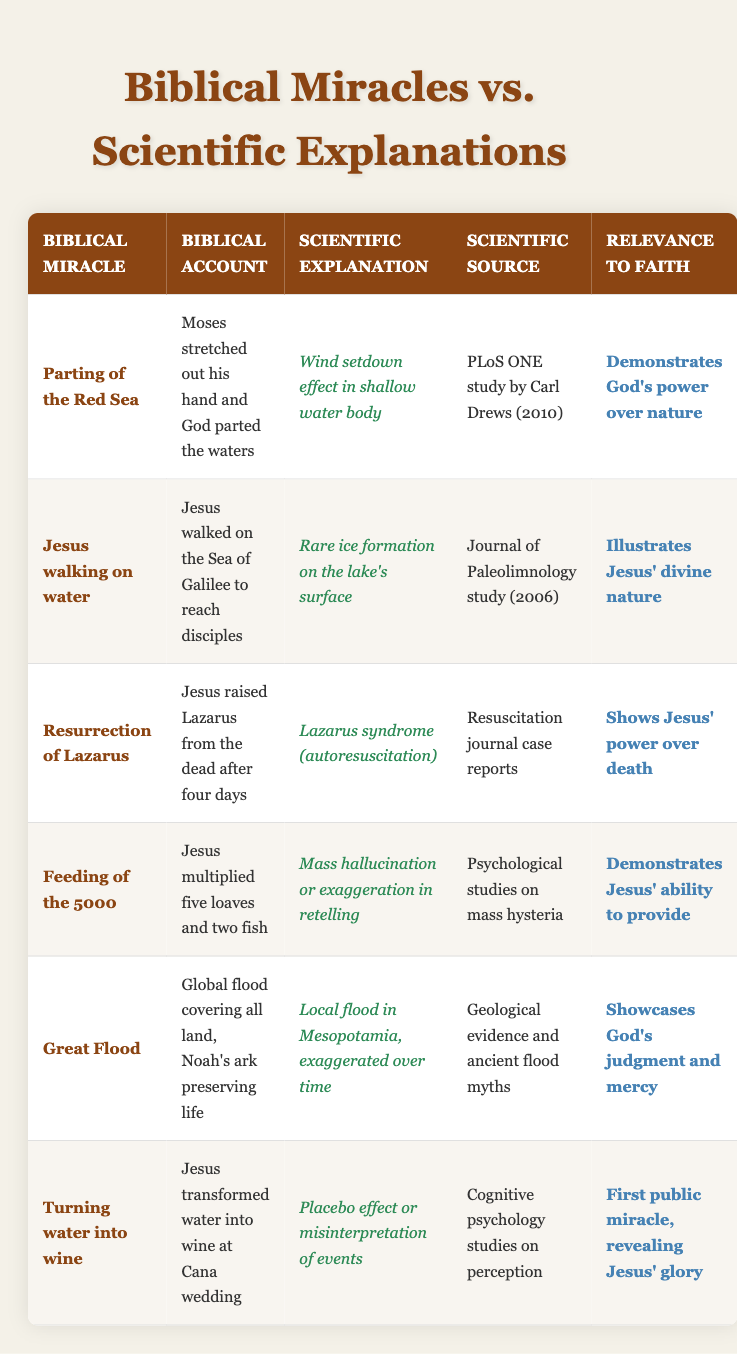What is the biblical account for the miracle of the Great Flood? The biblical account for the Great Flood states that there was a global flood covering all land, with Noah's ark preserving life. This detail can be found in the "Biblical Account" column for the Great Flood row in the table.
Answer: There was a global flood covering all land, Noah's ark preserving life What scientific explanation is provided for Jesus walking on water? The table lists the scientific explanation for Jesus walking on water as a rare ice formation on the lake's surface. This information is located in the "Scientific Explanation" column for the relevant miracle row.
Answer: Rare ice formation on the lake's surface How many miracles mentioned in the table showcase Jesus' power? To determine this, I will count the rows where the relevance to faith includes a demonstration of Jesus' power. The miracles are: Resurrection of Lazarus (power over death), Jesus walking on water (divine nature), and Feeding of the 5000 (ability to provide). Thus, there are three miracles.
Answer: 3 Is the scientific source for the Parting of the Red Sea a journal study? The source listed for the Parting of the Red Sea is the PLoS ONE study by Carl Drews (2010), which is indeed a scientific journal study. This confirmation can be derived from the "Scientific Source" column corresponding to that miracle.
Answer: Yes Which miracle has a relevance to faith related to God's judgment and mercy? The Great Flood miracle is noted for showcasing God's judgment and mercy. This can be identified by looking at the "Relevance to Faith" column for this particular miracle row.
Answer: Great Flood What is the relationship between the miracle of turning water into wine and Jesus' glory? The relevance to faith for the miracle of turning water into wine indicates that it was Jesus' first public miracle, revealing His glory. This idea is reflected in the "Relevance to Faith" column for that miracle.
Answer: Revealing Jesus' glory List the scientific sources for the miracles involving Lazarus and the Feeding of the 5000. The scientific source for the Resurrection of Lazarus is listed as Resuscitation journal case reports, and for the Feeding of the 5000, it is noted as psychological studies on mass hysteria. This information can be retrieved by looking at the "Scientific Source" column in those specific rows.
Answer: Resuscitation journal case reports; psychological studies on mass hysteria What was the main scientific explanation for the feeding of the 5000 miracle? According to the table, the scientific explanation for the miracle of the feeding of the 5000 is attributed to mass hallucination or exaggeration in retelling. This can be found in the "Scientific Explanation" column for that row.
Answer: Mass hallucination or exaggeration in retelling Which miracle has the most complex scientific explanation? Evaluating the different scientific explanations provided, the Resurrection of Lazarus with Lazarus syndrome (autoresuscitation) reflects a more complex scientific phenomenon and reasoning process compared to the other miracles. This assessment is based on the nuances involved in understanding the explanation.
Answer: Resurrection of Lazarus 